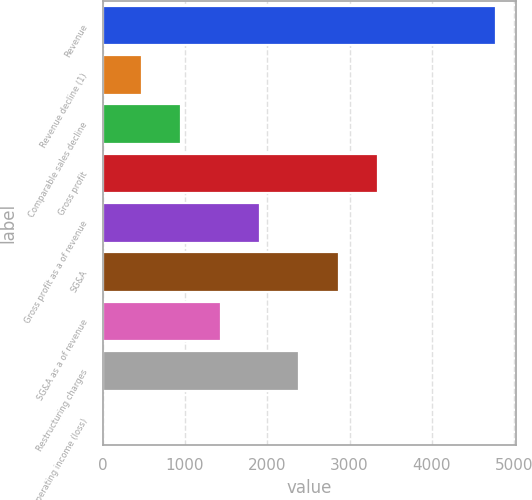Convert chart to OTSL. <chart><loc_0><loc_0><loc_500><loc_500><bar_chart><fcel>Revenue<fcel>Revenue decline (1)<fcel>Comparable sales decline<fcel>Gross profit<fcel>Gross profit as a of revenue<fcel>SG&A<fcel>SG&A as a of revenue<fcel>Restructuring charges<fcel>Operating income (loss)<nl><fcel>4780<fcel>478.9<fcel>956.8<fcel>3346.3<fcel>1912.6<fcel>2868.4<fcel>1434.7<fcel>2390.5<fcel>1<nl></chart> 